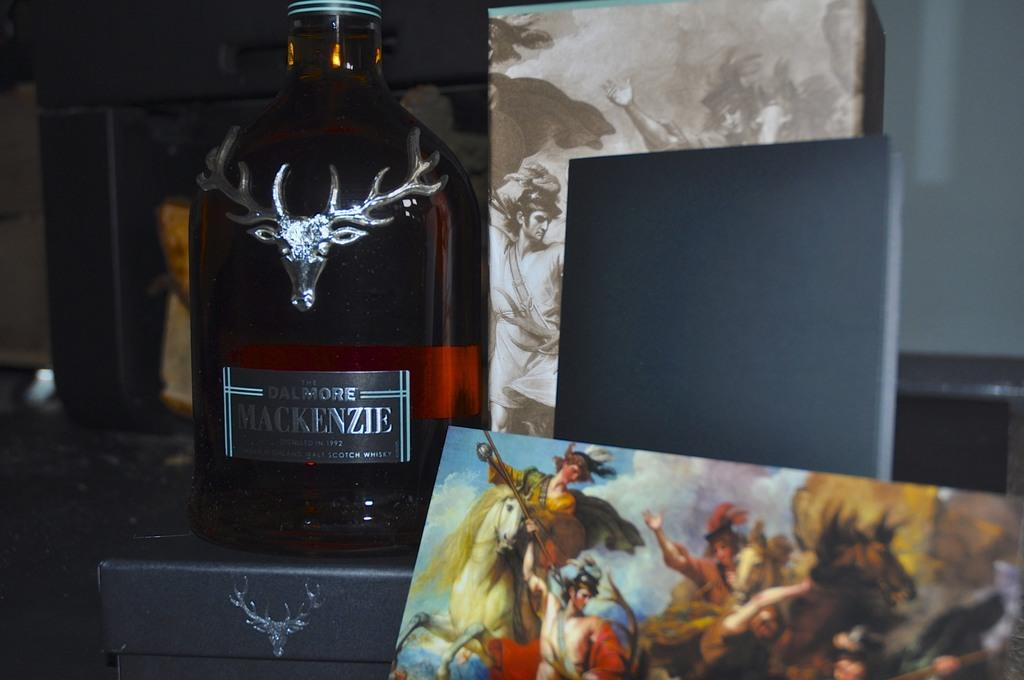<image>
Provide a brief description of the given image. A glass jar is labeled Mackenzie and has a deer on the front. 